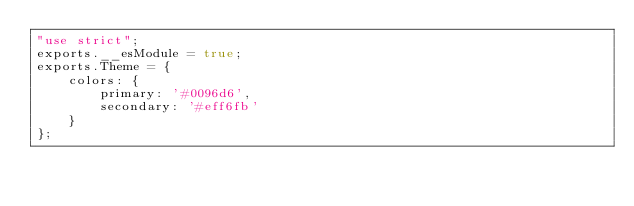Convert code to text. <code><loc_0><loc_0><loc_500><loc_500><_JavaScript_>"use strict";
exports.__esModule = true;
exports.Theme = {
    colors: {
        primary: '#0096d6',
        secondary: '#eff6fb'
    }
};
</code> 